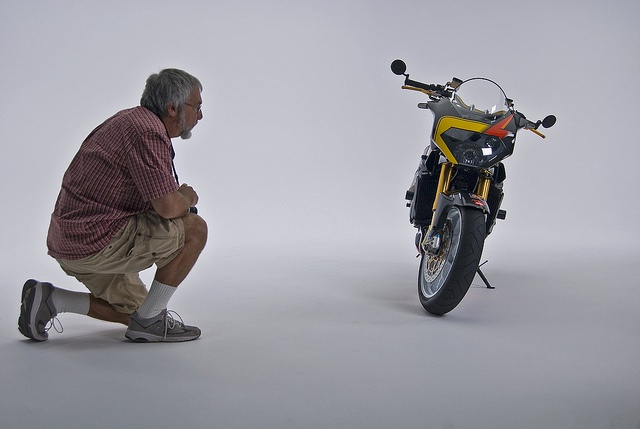Describe the objects in this image and their specific colors. I can see people in darkgray, gray, black, and maroon tones and motorcycle in darkgray, black, and gray tones in this image. 